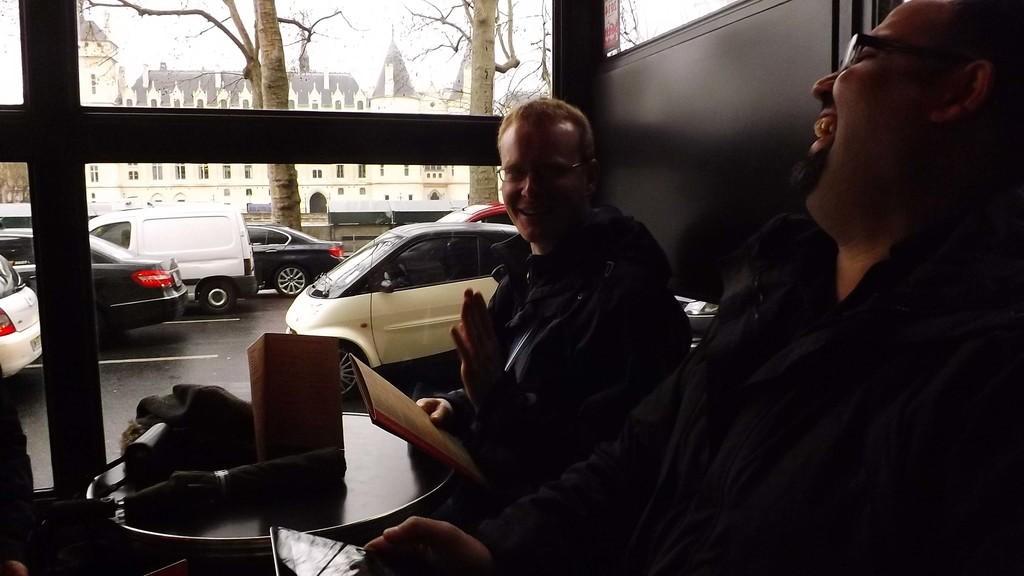Could you give a brief overview of what you see in this image? In this image we can see this person is holding a mobile phone in his hands and smiling and this person is holding a file in his hands and sitting near the table. Here we can see an umbrella, menu card and few things kept on the table. Here we can see glass windows through which we can see vehicles moving on the road, trees, buildings and sky in the background. 